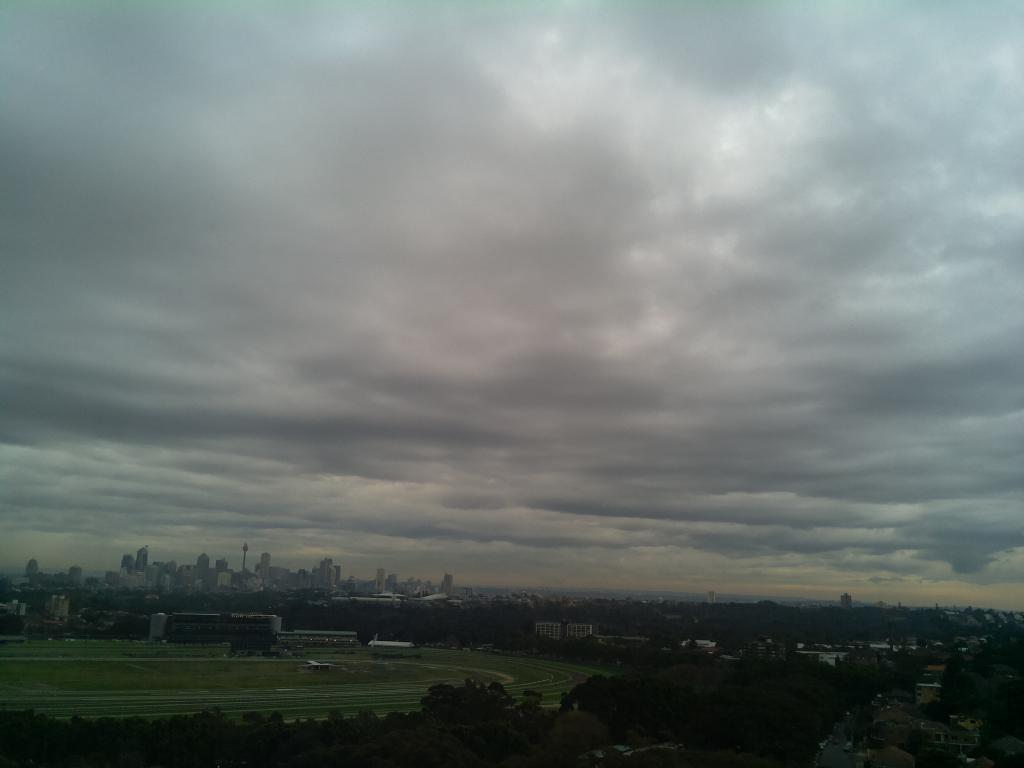What type of vegetation is present at the bottom of the image? There are trees at the bottom of the image. What type of structures are also present at the bottom of the image? There are buildings at the bottom of the image. What is covering the ground at the bottom of the image? There is grass on the ground at the bottom of the image. What can be seen in the sky in the background of the image? There are clouds in the sky in the background of the image. What type of distribution system is visible in the image? There is no distribution system present in the image. What season is depicted in the image? The provided facts do not mention any specific season, so it cannot be determined from the image. 